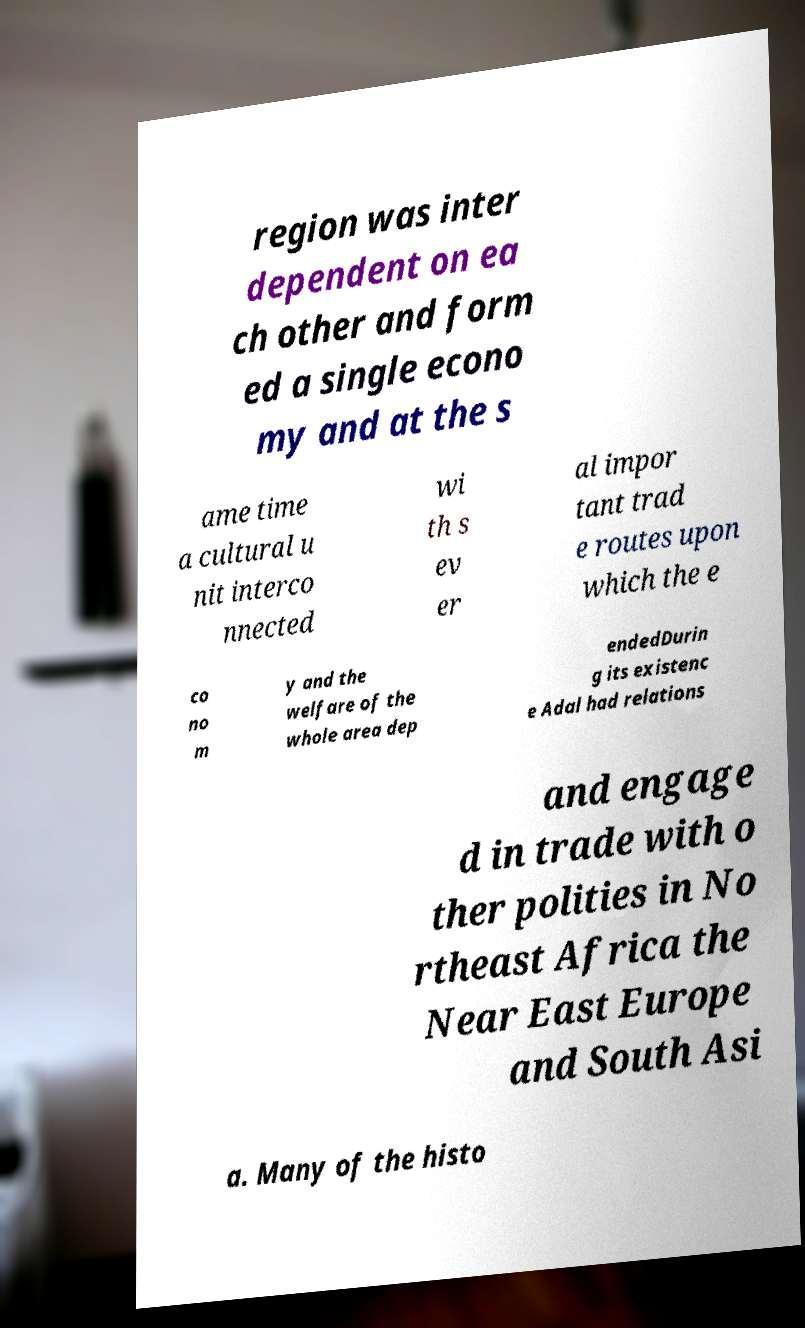What messages or text are displayed in this image? I need them in a readable, typed format. region was inter dependent on ea ch other and form ed a single econo my and at the s ame time a cultural u nit interco nnected wi th s ev er al impor tant trad e routes upon which the e co no m y and the welfare of the whole area dep endedDurin g its existenc e Adal had relations and engage d in trade with o ther polities in No rtheast Africa the Near East Europe and South Asi a. Many of the histo 